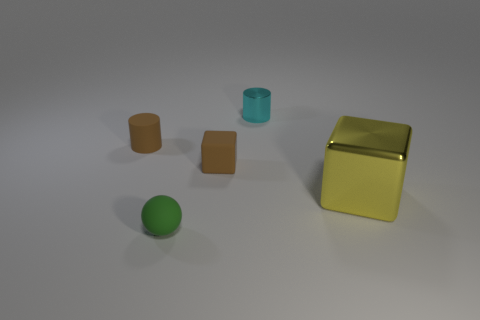Subtract all purple cylinders. Subtract all yellow balls. How many cylinders are left? 2 Add 4 blue spheres. How many objects exist? 9 Subtract all cylinders. How many objects are left? 3 Subtract 0 green cylinders. How many objects are left? 5 Subtract all big green cubes. Subtract all cyan metallic cylinders. How many objects are left? 4 Add 5 brown things. How many brown things are left? 7 Add 5 big blocks. How many big blocks exist? 6 